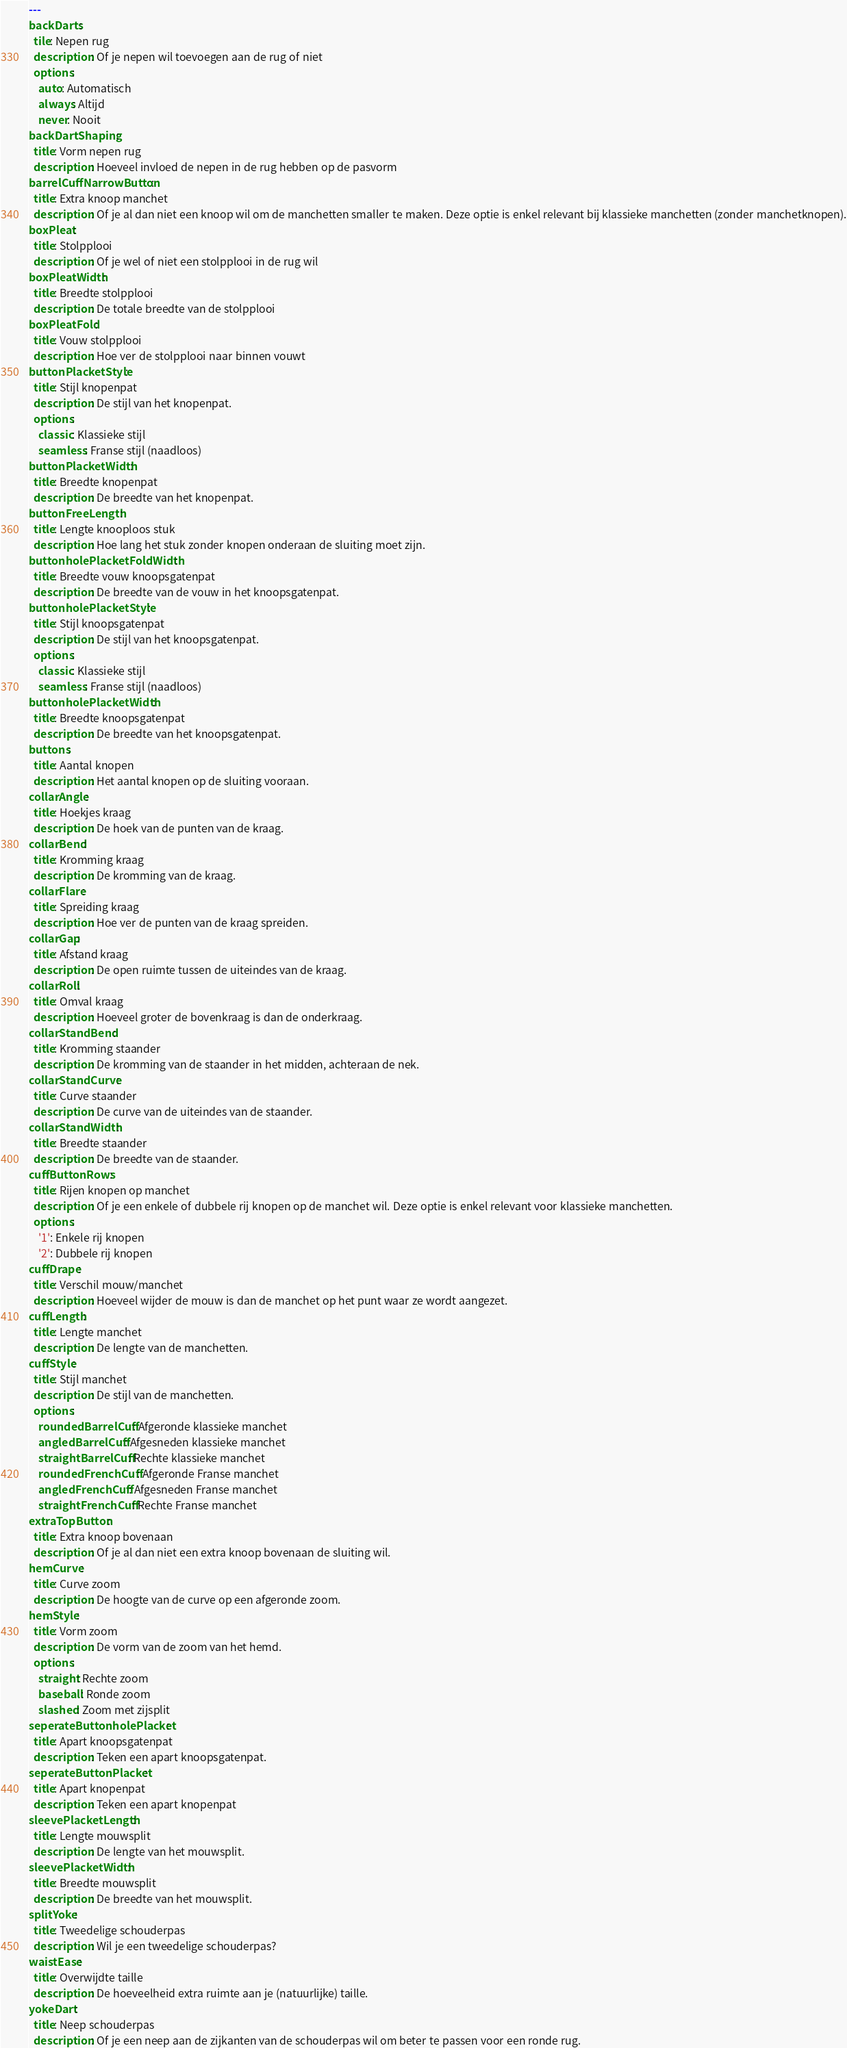<code> <loc_0><loc_0><loc_500><loc_500><_YAML_>---
backDarts:
  tile: Nepen rug
  description: Of je nepen wil toevoegen aan de rug of niet
  options:
    auto: Automatisch
    always: Altijd
    never: Nooit
backDartShaping:
  title: Vorm nepen rug
  description: Hoeveel invloed de nepen in de rug hebben op de pasvorm
barrelCuffNarrowButton:
  title: Extra knoop manchet
  description: Of je al dan niet een knoop wil om de manchetten smaller te maken. Deze optie is enkel relevant bij klassieke manchetten (zonder manchetknopen).
boxPleat:
  title: Stolpplooi
  description: Of je wel of niet een stolpplooi in de rug wil
boxPleatWidth:
  title: Breedte stolpplooi
  description: De totale breedte van de stolpplooi
boxPleatFold:
  title: Vouw stolpplooi
  description: Hoe ver de stolpplooi naar binnen vouwt
buttonPlacketStyle:
  title: Stijl knopenpat
  description: De stijl van het knopenpat.
  options:
    classic: Klassieke stijl
    seamless: Franse stijl (naadloos)
buttonPlacketWidth:
  title: Breedte knopenpat
  description: De breedte van het knopenpat.
buttonFreeLength:
  title: Lengte knooploos stuk
  description: Hoe lang het stuk zonder knopen onderaan de sluiting moet zijn.
buttonholePlacketFoldWidth:
  title: Breedte vouw knoopsgatenpat
  description: De breedte van de vouw in het knoopsgatenpat.
buttonholePlacketStyle:
  title: Stijl knoopsgatenpat
  description: De stijl van het knoopsgatenpat.
  options:
    classic: Klassieke stijl
    seamless: Franse stijl (naadloos)
buttonholePlacketWidth:
  title: Breedte knoopsgatenpat
  description: De breedte van het knoopsgatenpat.
buttons:
  title: Aantal knopen
  description: Het aantal knopen op de sluiting vooraan.
collarAngle:
  title: Hoekjes kraag
  description: De hoek van de punten van de kraag. 
collarBend:
  title: Kromming kraag
  description: De kromming van de kraag.
collarFlare:
  title: Spreiding kraag
  description: Hoe ver de punten van de kraag spreiden.
collarGap:
  title: Afstand kraag
  description: De open ruimte tussen de uiteindes van de kraag.
collarRoll:
  title: Omval kraag
  description: Hoeveel groter de bovenkraag is dan de onderkraag.
collarStandBend:
  title: Kromming staander
  description: De kromming van de staander in het midden, achteraan de nek.
collarStandCurve:
  title: Curve staander
  description: De curve van de uiteindes van de staander.
collarStandWidth:
  title: Breedte staander
  description: De breedte van de staander.
cuffButtonRows:
  title: Rijen knopen op manchet
  description: Of je een enkele of dubbele rij knopen op de manchet wil. Deze optie is enkel relevant voor klassieke manchetten.
  options:
    '1': Enkele rij knopen
    '2': Dubbele rij knopen
cuffDrape:
  title: Verschil mouw/manchet
  description: Hoeveel wijder de mouw is dan de manchet op het punt waar ze wordt aangezet.
cuffLength:
  title: Lengte manchet
  description: De lengte van de manchetten.
cuffStyle:
  title: Stijl manchet
  description: De stijl van de manchetten.
  options:
    roundedBarrelCuff: Afgeronde klassieke manchet
    angledBarrelCuff: Afgesneden klassieke manchet
    straightBarrelCuff: Rechte klassieke manchet
    roundedFrenchCuff: Afgeronde Franse manchet
    angledFrenchCuff: Afgesneden Franse manchet
    straightFrenchCuff: Rechte Franse manchet
extraTopButton:
  title: Extra knoop bovenaan
  description: Of je al dan niet een extra knoop bovenaan de sluiting wil.
hemCurve:
  title: Curve zoom
  description: De hoogte van de curve op een afgeronde zoom.
hemStyle:
  title: Vorm zoom
  description: De vorm van de zoom van het hemd.
  options:
    straight: Rechte zoom
    baseball: Ronde zoom
    slashed: Zoom met zijsplit
seperateButtonholePlacket:
  title: Apart knoopsgatenpat
  description: Teken een apart knoopsgatenpat.
seperateButtonPlacket:
  title: Apart knopenpat
  description: Teken een apart knopenpat
sleevePlacketLength:
  title: Lengte mouwsplit
  description: De lengte van het mouwsplit.
sleevePlacketWidth:
  title: Breedte mouwsplit
  description: De breedte van het mouwsplit.
splitYoke:
  title: Tweedelige schouderpas
  description: Wil je een tweedelige schouderpas?
waistEase:
  title: Overwijdte taille
  description: De hoeveelheid extra ruimte aan je (natuurlijke) taille.
yokeDart:
  title: Neep schouderpas
  description: Of je een neep aan de zijkanten van de schouderpas wil om beter te passen voor een ronde rug.
</code> 